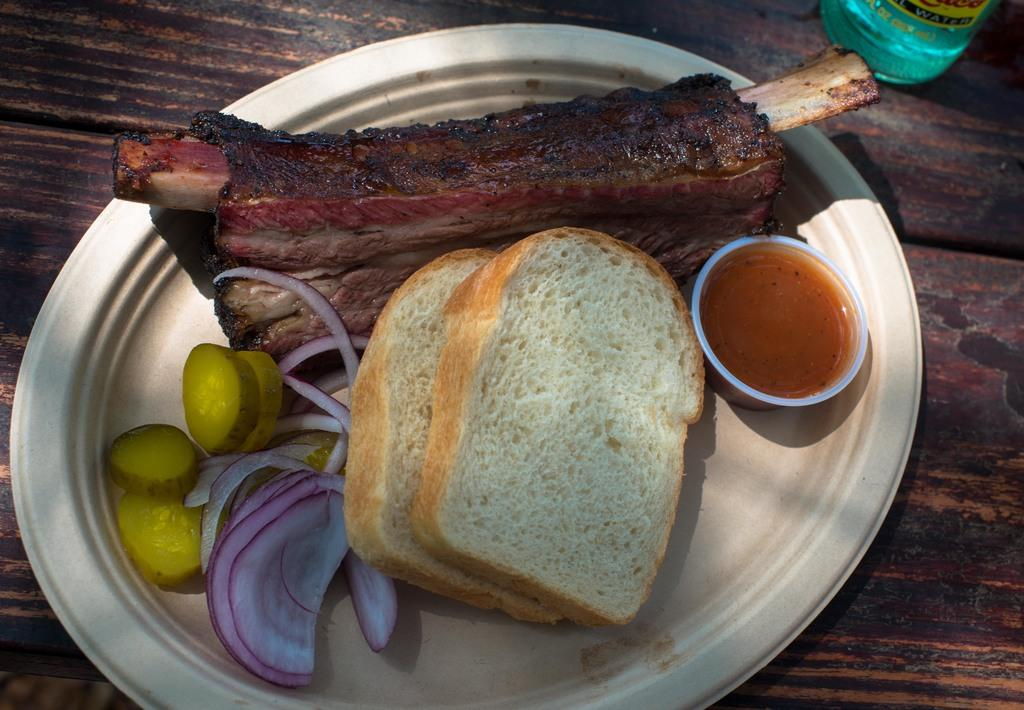What type of food can be seen in the image? There is meat in the image. What is the liquid substance in the cup in the image? There is sauce in a cup in the image. What type of bread is present in the image? There are slices of bread in the image. What type of vegetables are in the plate in the image? There are vegetables in a plate in the image. What material is the surface visible in the image? The wooden surface is visible in the image. What object is beside the wooden surface in the image? There is an object beside the wooden surface in the image. What type of notebook is visible on the wooden surface in the image? There is no notebook present on the wooden surface in the image. 